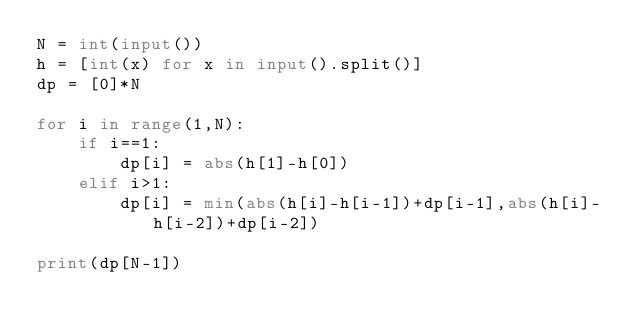Convert code to text. <code><loc_0><loc_0><loc_500><loc_500><_Python_>N = int(input())
h = [int(x) for x in input().split()]
dp = [0]*N

for i in range(1,N):
  	if i==1:
      	dp[i] = abs(h[1]-h[0])
    elif i>1:
      	dp[i] = min(abs(h[i]-h[i-1])+dp[i-1],abs(h[i]-h[i-2])+dp[i-2])
    
print(dp[N-1])</code> 